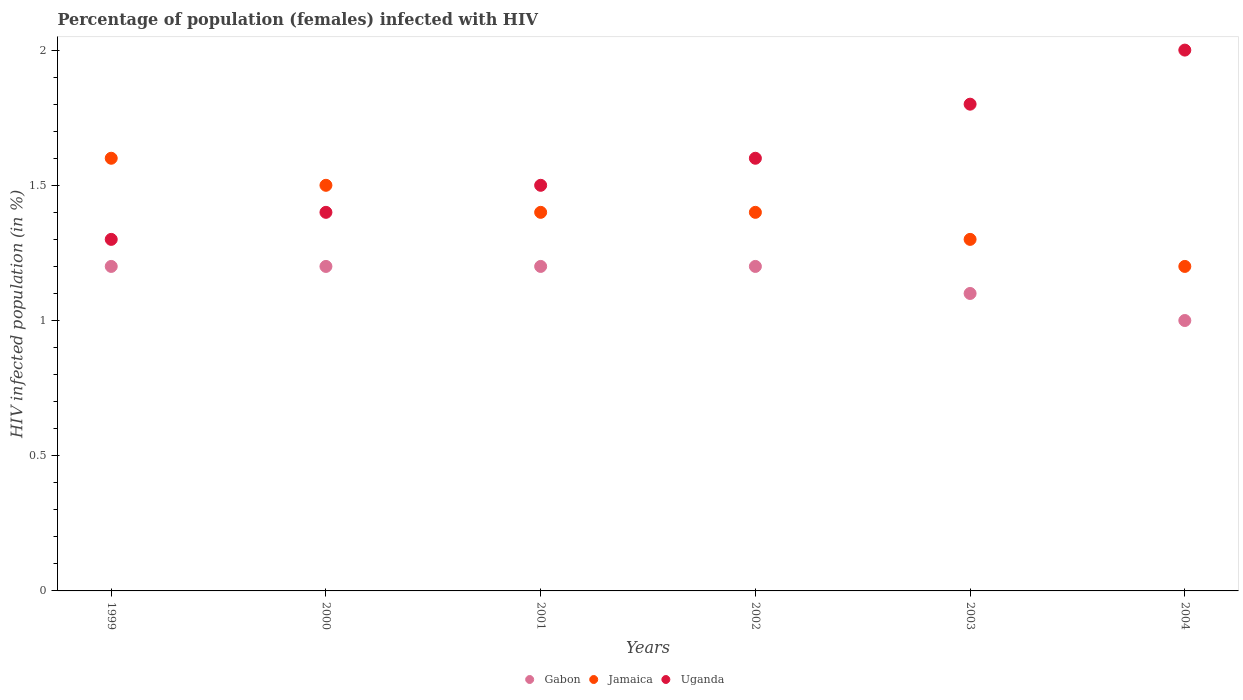How many different coloured dotlines are there?
Offer a very short reply. 3. Across all years, what is the maximum percentage of HIV infected female population in Uganda?
Give a very brief answer. 2. What is the total percentage of HIV infected female population in Uganda in the graph?
Provide a short and direct response. 9.6. What is the difference between the percentage of HIV infected female population in Gabon in 1999 and that in 2004?
Your answer should be compact. 0.2. What is the difference between the percentage of HIV infected female population in Uganda in 2002 and the percentage of HIV infected female population in Jamaica in 2001?
Your answer should be compact. 0.2. What is the average percentage of HIV infected female population in Jamaica per year?
Your answer should be compact. 1.4. In the year 1999, what is the difference between the percentage of HIV infected female population in Uganda and percentage of HIV infected female population in Gabon?
Your response must be concise. 0.1. What is the difference between the highest and the lowest percentage of HIV infected female population in Gabon?
Your answer should be compact. 0.2. In how many years, is the percentage of HIV infected female population in Uganda greater than the average percentage of HIV infected female population in Uganda taken over all years?
Your response must be concise. 2. Is it the case that in every year, the sum of the percentage of HIV infected female population in Jamaica and percentage of HIV infected female population in Uganda  is greater than the percentage of HIV infected female population in Gabon?
Keep it short and to the point. Yes. Is the percentage of HIV infected female population in Gabon strictly greater than the percentage of HIV infected female population in Jamaica over the years?
Offer a terse response. No. What is the difference between two consecutive major ticks on the Y-axis?
Keep it short and to the point. 0.5. Does the graph contain any zero values?
Provide a succinct answer. No. Does the graph contain grids?
Provide a short and direct response. No. What is the title of the graph?
Make the answer very short. Percentage of population (females) infected with HIV. What is the label or title of the Y-axis?
Offer a terse response. HIV infected population (in %). What is the HIV infected population (in %) of Jamaica in 2000?
Your response must be concise. 1.5. What is the HIV infected population (in %) of Uganda in 2000?
Your answer should be compact. 1.4. What is the HIV infected population (in %) in Gabon in 2001?
Provide a succinct answer. 1.2. What is the HIV infected population (in %) in Uganda in 2001?
Provide a short and direct response. 1.5. What is the HIV infected population (in %) of Uganda in 2002?
Provide a short and direct response. 1.6. What is the HIV infected population (in %) of Gabon in 2003?
Offer a terse response. 1.1. What is the HIV infected population (in %) of Jamaica in 2003?
Give a very brief answer. 1.3. What is the HIV infected population (in %) of Gabon in 2004?
Your response must be concise. 1. What is the HIV infected population (in %) of Uganda in 2004?
Ensure brevity in your answer.  2. Across all years, what is the maximum HIV infected population (in %) of Gabon?
Ensure brevity in your answer.  1.2. Across all years, what is the maximum HIV infected population (in %) of Jamaica?
Your answer should be compact. 1.6. Across all years, what is the minimum HIV infected population (in %) in Uganda?
Make the answer very short. 1.3. What is the total HIV infected population (in %) in Gabon in the graph?
Offer a terse response. 6.9. What is the total HIV infected population (in %) of Uganda in the graph?
Provide a succinct answer. 9.6. What is the difference between the HIV infected population (in %) in Gabon in 1999 and that in 2000?
Provide a succinct answer. 0. What is the difference between the HIV infected population (in %) of Gabon in 1999 and that in 2001?
Your response must be concise. 0. What is the difference between the HIV infected population (in %) of Jamaica in 1999 and that in 2001?
Your answer should be very brief. 0.2. What is the difference between the HIV infected population (in %) in Gabon in 1999 and that in 2002?
Your answer should be compact. 0. What is the difference between the HIV infected population (in %) of Jamaica in 1999 and that in 2003?
Keep it short and to the point. 0.3. What is the difference between the HIV infected population (in %) in Uganda in 1999 and that in 2003?
Give a very brief answer. -0.5. What is the difference between the HIV infected population (in %) of Gabon in 1999 and that in 2004?
Your response must be concise. 0.2. What is the difference between the HIV infected population (in %) in Jamaica in 1999 and that in 2004?
Keep it short and to the point. 0.4. What is the difference between the HIV infected population (in %) of Jamaica in 2000 and that in 2001?
Your answer should be very brief. 0.1. What is the difference between the HIV infected population (in %) of Uganda in 2000 and that in 2001?
Provide a succinct answer. -0.1. What is the difference between the HIV infected population (in %) of Gabon in 2000 and that in 2002?
Provide a succinct answer. 0. What is the difference between the HIV infected population (in %) of Jamaica in 2000 and that in 2002?
Give a very brief answer. 0.1. What is the difference between the HIV infected population (in %) in Uganda in 2000 and that in 2002?
Keep it short and to the point. -0.2. What is the difference between the HIV infected population (in %) of Gabon in 2000 and that in 2003?
Provide a short and direct response. 0.1. What is the difference between the HIV infected population (in %) of Jamaica in 2000 and that in 2003?
Keep it short and to the point. 0.2. What is the difference between the HIV infected population (in %) of Uganda in 2000 and that in 2003?
Give a very brief answer. -0.4. What is the difference between the HIV infected population (in %) of Gabon in 2000 and that in 2004?
Provide a short and direct response. 0.2. What is the difference between the HIV infected population (in %) in Uganda in 2000 and that in 2004?
Your answer should be compact. -0.6. What is the difference between the HIV infected population (in %) in Jamaica in 2001 and that in 2002?
Keep it short and to the point. 0. What is the difference between the HIV infected population (in %) of Gabon in 2001 and that in 2003?
Your answer should be very brief. 0.1. What is the difference between the HIV infected population (in %) in Gabon in 2001 and that in 2004?
Provide a succinct answer. 0.2. What is the difference between the HIV infected population (in %) in Uganda in 2001 and that in 2004?
Your response must be concise. -0.5. What is the difference between the HIV infected population (in %) of Gabon in 2002 and that in 2003?
Give a very brief answer. 0.1. What is the difference between the HIV infected population (in %) of Jamaica in 2002 and that in 2003?
Keep it short and to the point. 0.1. What is the difference between the HIV infected population (in %) of Gabon in 2002 and that in 2004?
Your answer should be compact. 0.2. What is the difference between the HIV infected population (in %) in Jamaica in 2002 and that in 2004?
Your answer should be compact. 0.2. What is the difference between the HIV infected population (in %) of Gabon in 2003 and that in 2004?
Ensure brevity in your answer.  0.1. What is the difference between the HIV infected population (in %) in Jamaica in 2003 and that in 2004?
Your answer should be compact. 0.1. What is the difference between the HIV infected population (in %) in Gabon in 1999 and the HIV infected population (in %) in Jamaica in 2000?
Your answer should be compact. -0.3. What is the difference between the HIV infected population (in %) in Gabon in 1999 and the HIV infected population (in %) in Uganda in 2000?
Provide a short and direct response. -0.2. What is the difference between the HIV infected population (in %) of Gabon in 1999 and the HIV infected population (in %) of Jamaica in 2001?
Offer a very short reply. -0.2. What is the difference between the HIV infected population (in %) in Gabon in 1999 and the HIV infected population (in %) in Jamaica in 2002?
Ensure brevity in your answer.  -0.2. What is the difference between the HIV infected population (in %) in Jamaica in 1999 and the HIV infected population (in %) in Uganda in 2002?
Give a very brief answer. 0. What is the difference between the HIV infected population (in %) in Gabon in 1999 and the HIV infected population (in %) in Jamaica in 2003?
Your answer should be very brief. -0.1. What is the difference between the HIV infected population (in %) of Gabon in 1999 and the HIV infected population (in %) of Uganda in 2003?
Give a very brief answer. -0.6. What is the difference between the HIV infected population (in %) in Jamaica in 1999 and the HIV infected population (in %) in Uganda in 2003?
Your response must be concise. -0.2. What is the difference between the HIV infected population (in %) in Gabon in 1999 and the HIV infected population (in %) in Uganda in 2004?
Offer a terse response. -0.8. What is the difference between the HIV infected population (in %) in Jamaica in 1999 and the HIV infected population (in %) in Uganda in 2004?
Your answer should be very brief. -0.4. What is the difference between the HIV infected population (in %) of Gabon in 2000 and the HIV infected population (in %) of Jamaica in 2001?
Make the answer very short. -0.2. What is the difference between the HIV infected population (in %) of Gabon in 2000 and the HIV infected population (in %) of Uganda in 2001?
Ensure brevity in your answer.  -0.3. What is the difference between the HIV infected population (in %) in Jamaica in 2000 and the HIV infected population (in %) in Uganda in 2001?
Your response must be concise. 0. What is the difference between the HIV infected population (in %) of Jamaica in 2000 and the HIV infected population (in %) of Uganda in 2002?
Offer a very short reply. -0.1. What is the difference between the HIV infected population (in %) of Gabon in 2000 and the HIV infected population (in %) of Jamaica in 2004?
Offer a terse response. 0. What is the difference between the HIV infected population (in %) in Jamaica in 2000 and the HIV infected population (in %) in Uganda in 2004?
Provide a succinct answer. -0.5. What is the difference between the HIV infected population (in %) of Gabon in 2001 and the HIV infected population (in %) of Uganda in 2003?
Offer a very short reply. -0.6. What is the difference between the HIV infected population (in %) in Jamaica in 2002 and the HIV infected population (in %) in Uganda in 2003?
Provide a short and direct response. -0.4. What is the difference between the HIV infected population (in %) in Gabon in 2002 and the HIV infected population (in %) in Jamaica in 2004?
Provide a succinct answer. 0. What is the difference between the HIV infected population (in %) of Jamaica in 2002 and the HIV infected population (in %) of Uganda in 2004?
Your answer should be very brief. -0.6. What is the difference between the HIV infected population (in %) in Gabon in 2003 and the HIV infected population (in %) in Jamaica in 2004?
Provide a short and direct response. -0.1. What is the difference between the HIV infected population (in %) of Jamaica in 2003 and the HIV infected population (in %) of Uganda in 2004?
Keep it short and to the point. -0.7. What is the average HIV infected population (in %) of Gabon per year?
Provide a succinct answer. 1.15. What is the average HIV infected population (in %) in Jamaica per year?
Offer a very short reply. 1.4. What is the average HIV infected population (in %) of Uganda per year?
Make the answer very short. 1.6. In the year 1999, what is the difference between the HIV infected population (in %) of Jamaica and HIV infected population (in %) of Uganda?
Keep it short and to the point. 0.3. In the year 2001, what is the difference between the HIV infected population (in %) of Gabon and HIV infected population (in %) of Jamaica?
Give a very brief answer. -0.2. In the year 2002, what is the difference between the HIV infected population (in %) of Gabon and HIV infected population (in %) of Uganda?
Make the answer very short. -0.4. In the year 2003, what is the difference between the HIV infected population (in %) in Jamaica and HIV infected population (in %) in Uganda?
Your response must be concise. -0.5. In the year 2004, what is the difference between the HIV infected population (in %) in Gabon and HIV infected population (in %) in Jamaica?
Provide a short and direct response. -0.2. In the year 2004, what is the difference between the HIV infected population (in %) of Jamaica and HIV infected population (in %) of Uganda?
Make the answer very short. -0.8. What is the ratio of the HIV infected population (in %) in Gabon in 1999 to that in 2000?
Your answer should be compact. 1. What is the ratio of the HIV infected population (in %) of Jamaica in 1999 to that in 2000?
Your answer should be very brief. 1.07. What is the ratio of the HIV infected population (in %) in Uganda in 1999 to that in 2000?
Ensure brevity in your answer.  0.93. What is the ratio of the HIV infected population (in %) in Gabon in 1999 to that in 2001?
Offer a terse response. 1. What is the ratio of the HIV infected population (in %) in Uganda in 1999 to that in 2001?
Provide a short and direct response. 0.87. What is the ratio of the HIV infected population (in %) in Gabon in 1999 to that in 2002?
Offer a very short reply. 1. What is the ratio of the HIV infected population (in %) in Uganda in 1999 to that in 2002?
Give a very brief answer. 0.81. What is the ratio of the HIV infected population (in %) of Jamaica in 1999 to that in 2003?
Provide a succinct answer. 1.23. What is the ratio of the HIV infected population (in %) of Uganda in 1999 to that in 2003?
Your answer should be compact. 0.72. What is the ratio of the HIV infected population (in %) of Gabon in 1999 to that in 2004?
Your answer should be very brief. 1.2. What is the ratio of the HIV infected population (in %) of Jamaica in 1999 to that in 2004?
Your answer should be very brief. 1.33. What is the ratio of the HIV infected population (in %) in Uganda in 1999 to that in 2004?
Offer a terse response. 0.65. What is the ratio of the HIV infected population (in %) in Jamaica in 2000 to that in 2001?
Offer a terse response. 1.07. What is the ratio of the HIV infected population (in %) in Uganda in 2000 to that in 2001?
Ensure brevity in your answer.  0.93. What is the ratio of the HIV infected population (in %) in Jamaica in 2000 to that in 2002?
Your response must be concise. 1.07. What is the ratio of the HIV infected population (in %) of Gabon in 2000 to that in 2003?
Make the answer very short. 1.09. What is the ratio of the HIV infected population (in %) in Jamaica in 2000 to that in 2003?
Give a very brief answer. 1.15. What is the ratio of the HIV infected population (in %) of Gabon in 2000 to that in 2004?
Your answer should be very brief. 1.2. What is the ratio of the HIV infected population (in %) in Gabon in 2001 to that in 2002?
Your response must be concise. 1. What is the ratio of the HIV infected population (in %) of Jamaica in 2001 to that in 2002?
Give a very brief answer. 1. What is the ratio of the HIV infected population (in %) in Uganda in 2001 to that in 2002?
Offer a very short reply. 0.94. What is the ratio of the HIV infected population (in %) of Jamaica in 2001 to that in 2003?
Your response must be concise. 1.08. What is the ratio of the HIV infected population (in %) in Gabon in 2001 to that in 2004?
Keep it short and to the point. 1.2. What is the ratio of the HIV infected population (in %) in Uganda in 2001 to that in 2004?
Your answer should be compact. 0.75. What is the ratio of the HIV infected population (in %) in Jamaica in 2002 to that in 2003?
Make the answer very short. 1.08. What is the ratio of the HIV infected population (in %) of Gabon in 2002 to that in 2004?
Provide a short and direct response. 1.2. What is the ratio of the HIV infected population (in %) in Jamaica in 2002 to that in 2004?
Keep it short and to the point. 1.17. What is the ratio of the HIV infected population (in %) of Uganda in 2002 to that in 2004?
Your response must be concise. 0.8. What is the ratio of the HIV infected population (in %) of Gabon in 2003 to that in 2004?
Ensure brevity in your answer.  1.1. What is the ratio of the HIV infected population (in %) in Jamaica in 2003 to that in 2004?
Offer a terse response. 1.08. What is the difference between the highest and the second highest HIV infected population (in %) in Jamaica?
Your answer should be compact. 0.1. What is the difference between the highest and the lowest HIV infected population (in %) in Gabon?
Your response must be concise. 0.2. 